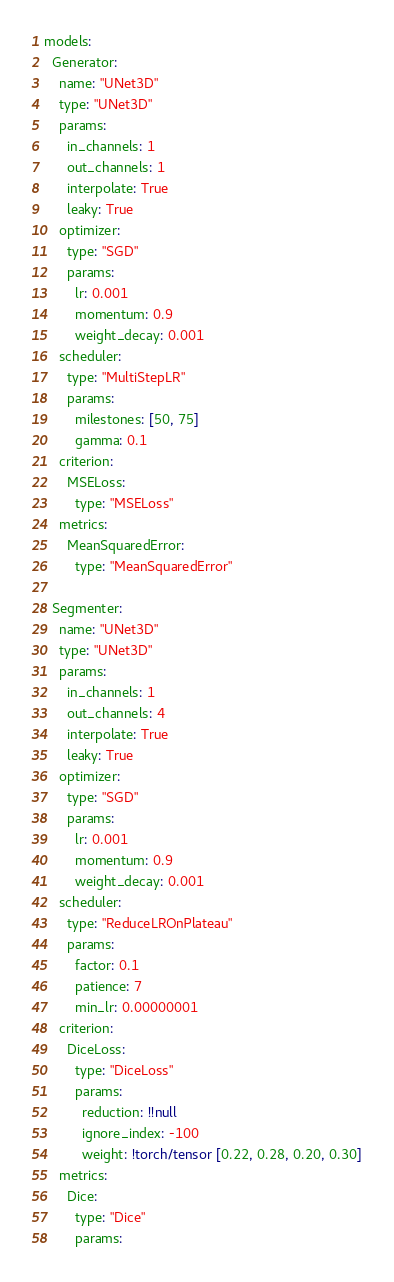<code> <loc_0><loc_0><loc_500><loc_500><_YAML_>models:
  Generator:
    name: "UNet3D"
    type: "UNet3D"
    params:
      in_channels: 1
      out_channels: 1
      interpolate: True
      leaky: True
    optimizer:
      type: "SGD"
      params:
        lr: 0.001
        momentum: 0.9
        weight_decay: 0.001
    scheduler:
      type: "MultiStepLR"
      params:
        milestones: [50, 75]
        gamma: 0.1
    criterion:
      MSELoss:
        type: "MSELoss"
    metrics:
      MeanSquaredError:
        type: "MeanSquaredError"

  Segmenter:
    name: "UNet3D"
    type: "UNet3D"
    params:
      in_channels: 1
      out_channels: 4
      interpolate: True
      leaky: True
    optimizer:
      type: "SGD"
      params:
        lr: 0.001
        momentum: 0.9
        weight_decay: 0.001
    scheduler:
      type: "ReduceLROnPlateau"
      params:
        factor: 0.1
        patience: 7
        min_lr: 0.00000001
    criterion:
      DiceLoss:
        type: "DiceLoss"
        params:
          reduction: !!null
          ignore_index: -100
          weight: !torch/tensor [0.22, 0.28, 0.20, 0.30]
    metrics:
      Dice:
        type: "Dice"
        params:</code> 